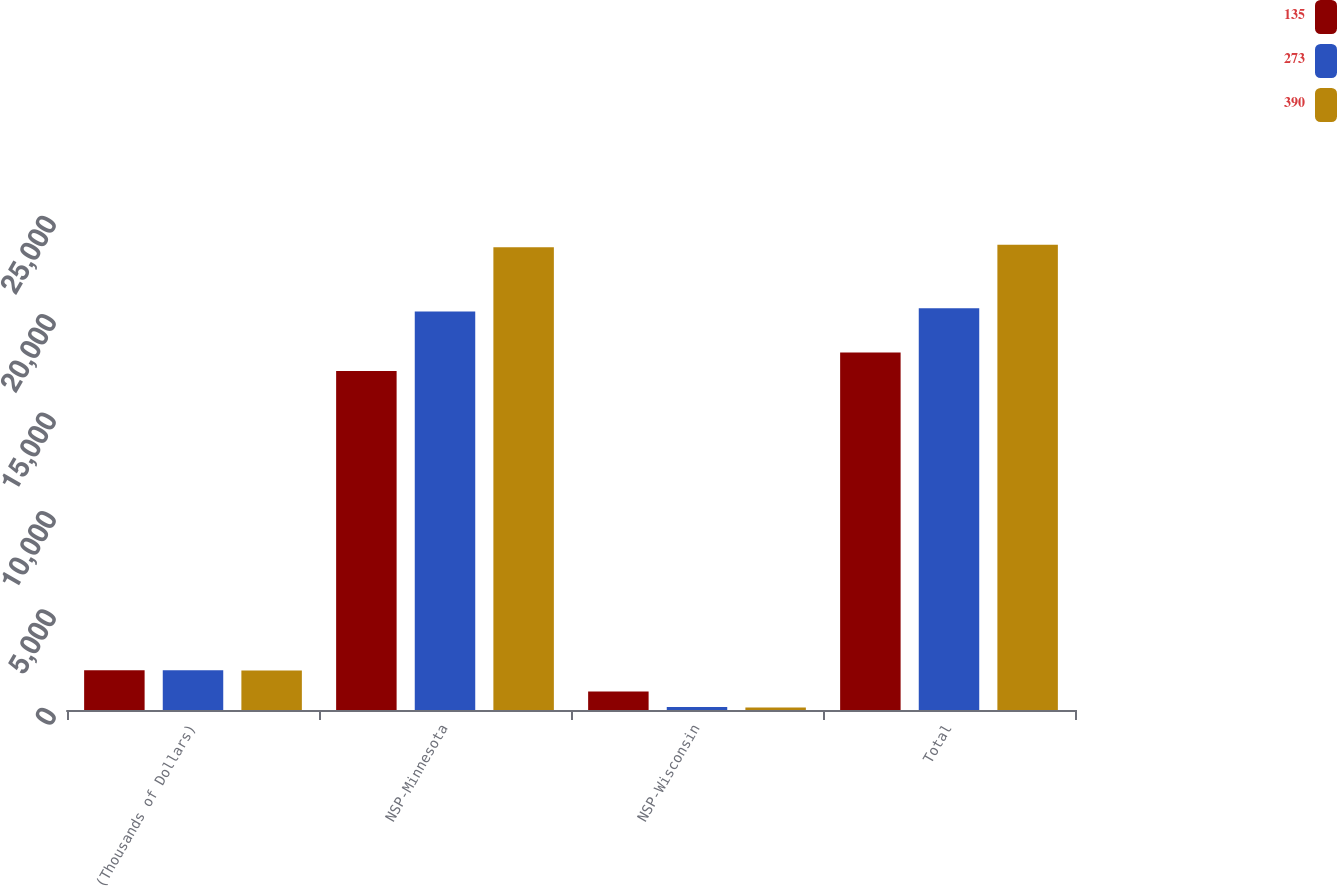Convert chart to OTSL. <chart><loc_0><loc_0><loc_500><loc_500><stacked_bar_chart><ecel><fcel>(Thousands of Dollars)<fcel>NSP-Minnesota<fcel>NSP-Wisconsin<fcel>Total<nl><fcel>135<fcel>2015<fcel>17223<fcel>944<fcel>18167<nl><fcel>273<fcel>2014<fcel>20254<fcel>156<fcel>20410<nl><fcel>390<fcel>2013<fcel>23515<fcel>130<fcel>23645<nl></chart> 